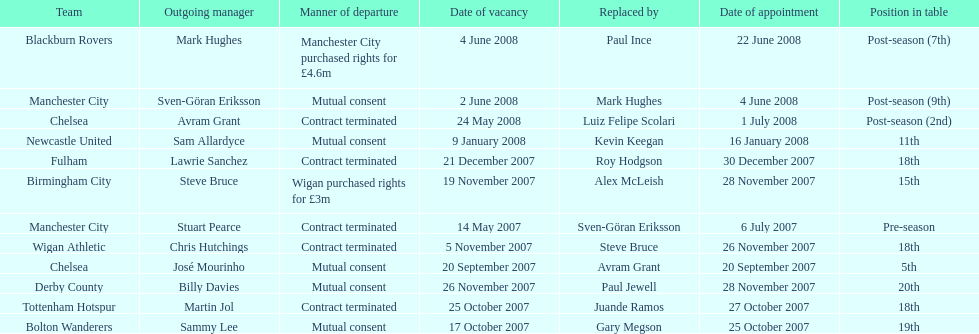What was the top team according to position in table called? Manchester City. 